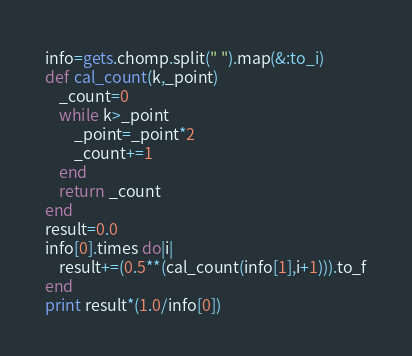<code> <loc_0><loc_0><loc_500><loc_500><_Ruby_>info=gets.chomp.split(" ").map(&:to_i)
def cal_count(k,_point)
	_count=0
	while k>_point
		_point=_point*2
		_count+=1
	end 
	return _count
end
result=0.0
info[0].times do|i|
	result+=(0.5**(cal_count(info[1],i+1))).to_f
end
print result*(1.0/info[0])
</code> 